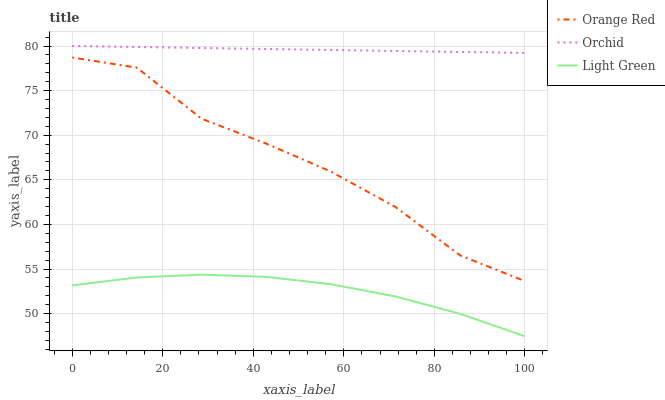Does Light Green have the minimum area under the curve?
Answer yes or no. Yes. Does Orchid have the maximum area under the curve?
Answer yes or no. Yes. Does Orchid have the minimum area under the curve?
Answer yes or no. No. Does Light Green have the maximum area under the curve?
Answer yes or no. No. Is Orchid the smoothest?
Answer yes or no. Yes. Is Orange Red the roughest?
Answer yes or no. Yes. Is Light Green the smoothest?
Answer yes or no. No. Is Light Green the roughest?
Answer yes or no. No. Does Orchid have the lowest value?
Answer yes or no. No. Does Light Green have the highest value?
Answer yes or no. No. Is Orange Red less than Orchid?
Answer yes or no. Yes. Is Orchid greater than Orange Red?
Answer yes or no. Yes. Does Orange Red intersect Orchid?
Answer yes or no. No. 